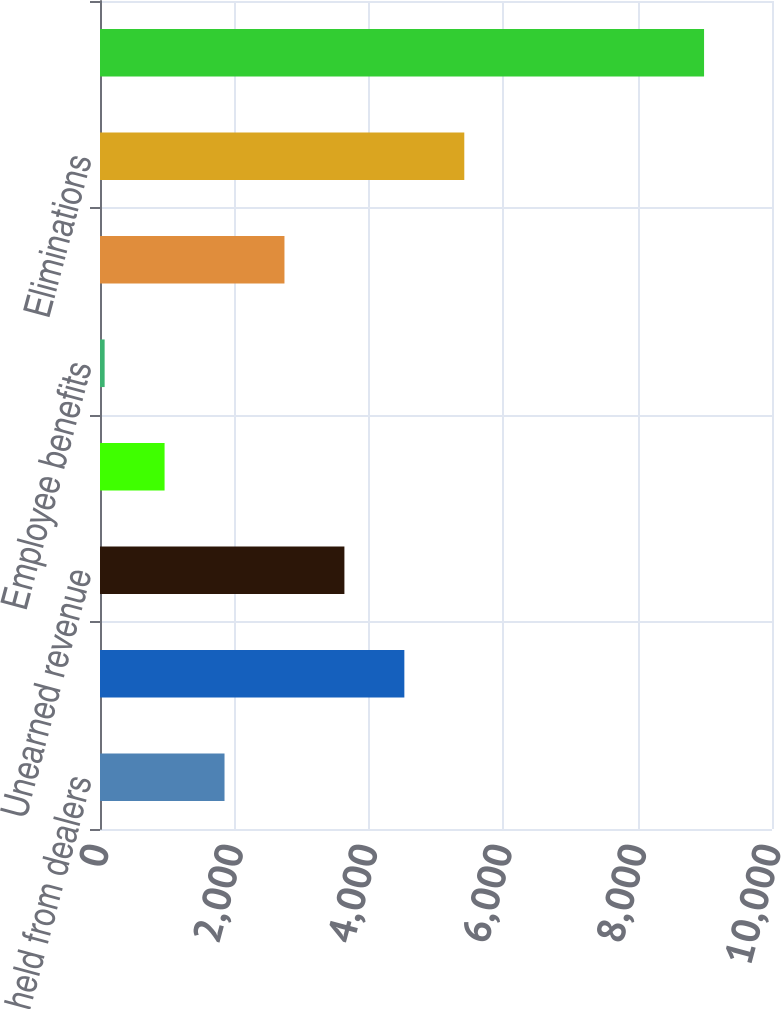Convert chart. <chart><loc_0><loc_0><loc_500><loc_500><bar_chart><fcel>Deposits withheld from dealers<fcel>Other<fcel>Unearned revenue<fcel>Accrued interest<fcel>Employee benefits<fcel>Insurance claims reserve<fcel>Eliminations<fcel>Accounts payable and accrued<nl><fcel>1853<fcel>4529<fcel>3637<fcel>961<fcel>69<fcel>2745<fcel>5421<fcel>8989<nl></chart> 